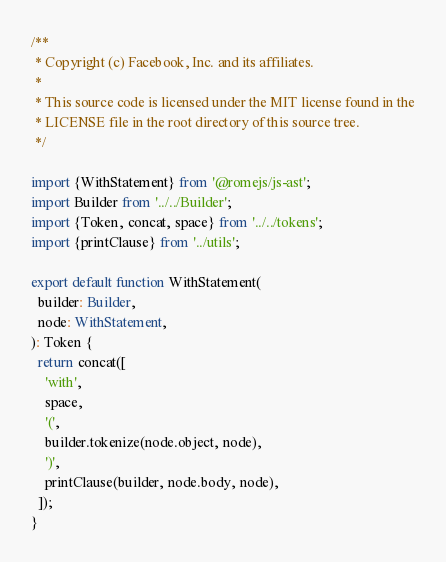<code> <loc_0><loc_0><loc_500><loc_500><_TypeScript_>/**
 * Copyright (c) Facebook, Inc. and its affiliates.
 *
 * This source code is licensed under the MIT license found in the
 * LICENSE file in the root directory of this source tree.
 */

import {WithStatement} from '@romejs/js-ast';
import Builder from '../../Builder';
import {Token, concat, space} from '../../tokens';
import {printClause} from '../utils';

export default function WithStatement(
  builder: Builder,
  node: WithStatement,
): Token {
  return concat([
    'with',
    space,
    '(',
    builder.tokenize(node.object, node),
    ')',
    printClause(builder, node.body, node),
  ]);
}
</code> 